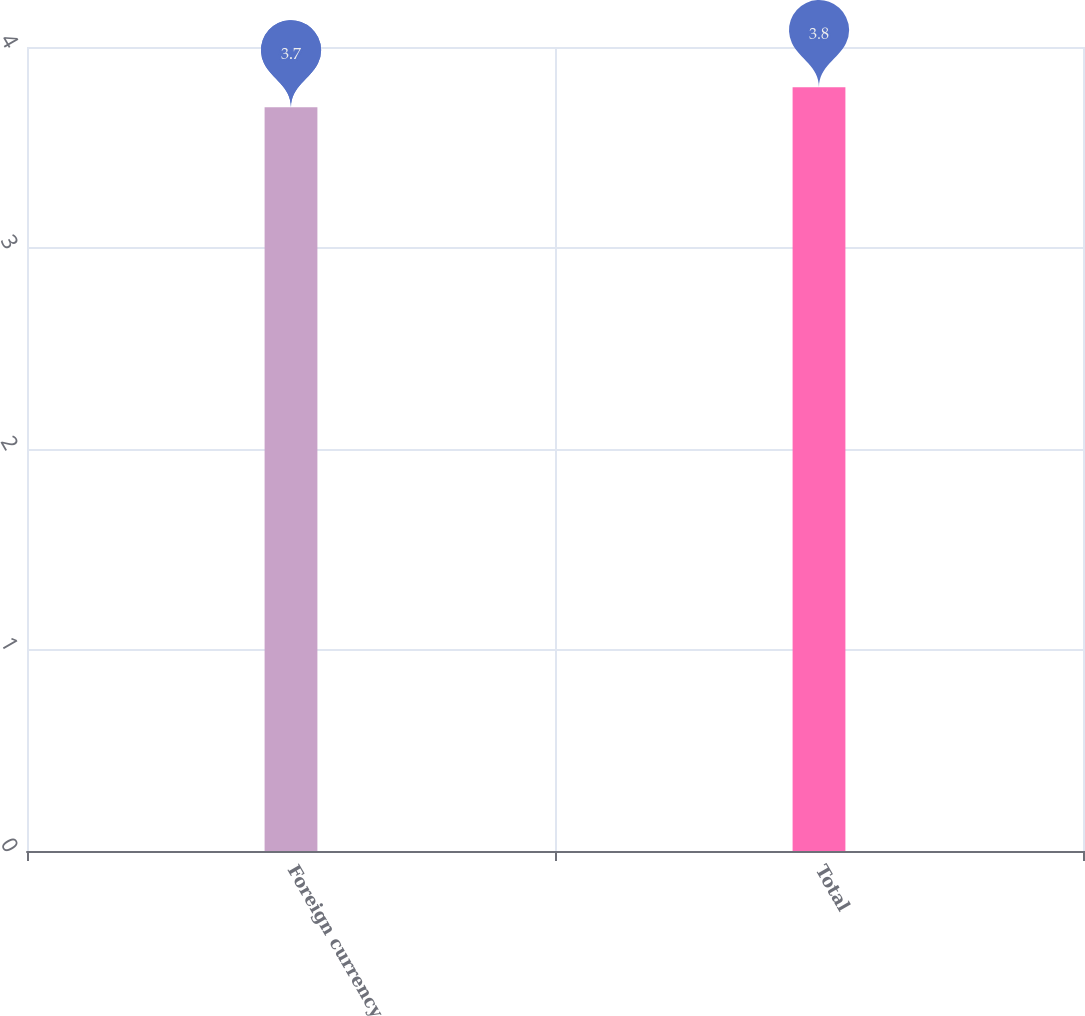Convert chart to OTSL. <chart><loc_0><loc_0><loc_500><loc_500><bar_chart><fcel>Foreign currency<fcel>Total<nl><fcel>3.7<fcel>3.8<nl></chart> 